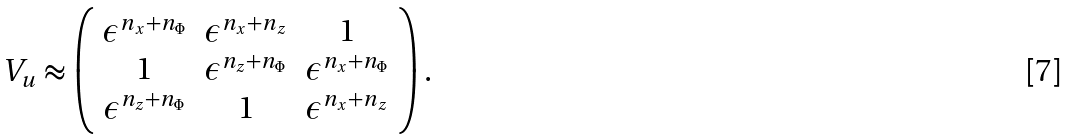Convert formula to latex. <formula><loc_0><loc_0><loc_500><loc_500>V _ { u } \approx \left ( \begin{array} { c c c } \epsilon ^ { n _ { x } + n _ { \Phi } } & \epsilon ^ { n _ { x } + n _ { z } } & 1 \\ 1 & \epsilon ^ { n _ { z } + n _ { \Phi } } & \epsilon ^ { n _ { x } + n _ { \Phi } } \\ \epsilon ^ { n _ { z } + n _ { \Phi } } & 1 & \epsilon ^ { n _ { x } + n _ { z } } \end{array} \right ) .</formula> 